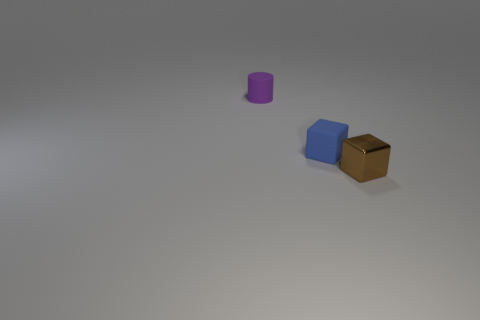Add 3 small cubes. How many objects exist? 6 Subtract all brown cubes. How many cubes are left? 1 Subtract 0 red cylinders. How many objects are left? 3 Subtract all cylinders. How many objects are left? 2 Subtract 1 cubes. How many cubes are left? 1 Subtract all brown cylinders. Subtract all red spheres. How many cylinders are left? 1 Subtract all blue cubes. How many yellow cylinders are left? 0 Subtract all blue balls. Subtract all tiny brown objects. How many objects are left? 2 Add 2 blue matte objects. How many blue matte objects are left? 3 Add 2 small blue cubes. How many small blue cubes exist? 3 